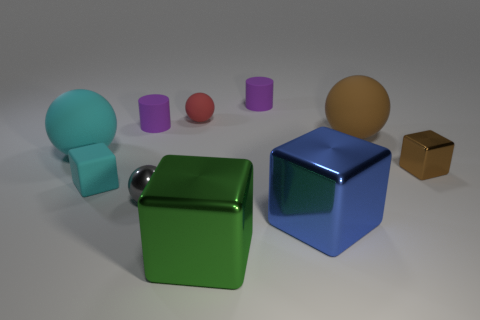Subtract all gray balls. How many balls are left? 3 Subtract all shiny spheres. How many spheres are left? 3 Subtract all cubes. How many objects are left? 6 Subtract 2 balls. How many balls are left? 2 Subtract all blue balls. Subtract all red cylinders. How many balls are left? 4 Subtract all purple cylinders. How many blue blocks are left? 1 Subtract all purple metallic cylinders. Subtract all large brown objects. How many objects are left? 9 Add 7 tiny purple matte things. How many tiny purple matte things are left? 9 Add 9 small purple metallic cylinders. How many small purple metallic cylinders exist? 9 Subtract 0 red blocks. How many objects are left? 10 